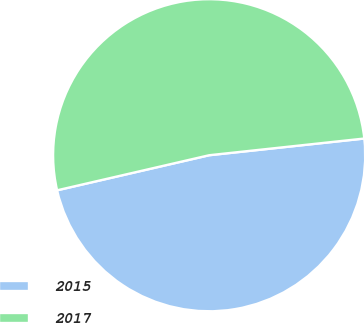Convert chart to OTSL. <chart><loc_0><loc_0><loc_500><loc_500><pie_chart><fcel>2015<fcel>2017<nl><fcel>48.1%<fcel>51.9%<nl></chart> 